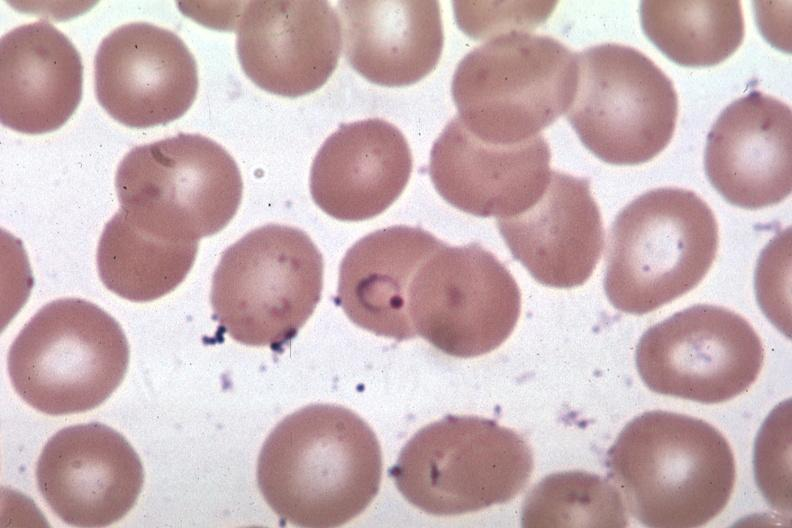does this image show oil wrights excellent ring form?
Answer the question using a single word or phrase. Yes 